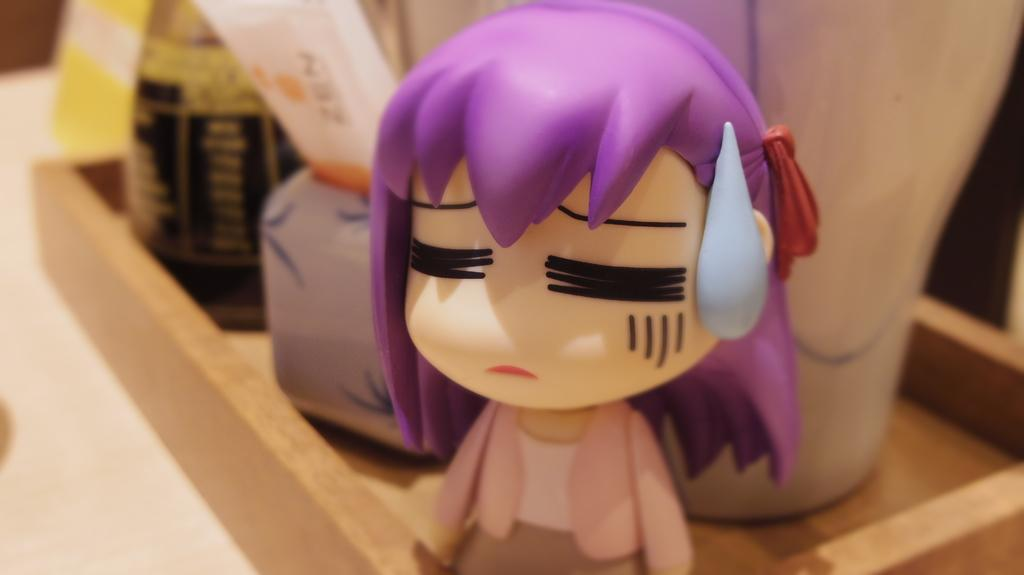What is the main object in the image? There is a toy in the image. What can be seen in the background of the image? There is a bottle and other objects on a wooden tray in the background of the image. How would you describe the background of the image? The background of the image is blurred. Can you see a wound on the toy in the image? There is no wound visible on the toy in the image. What side of the toy is facing the camera in the image? The image does not provide enough information to determine which side of the toy is facing the camera. 